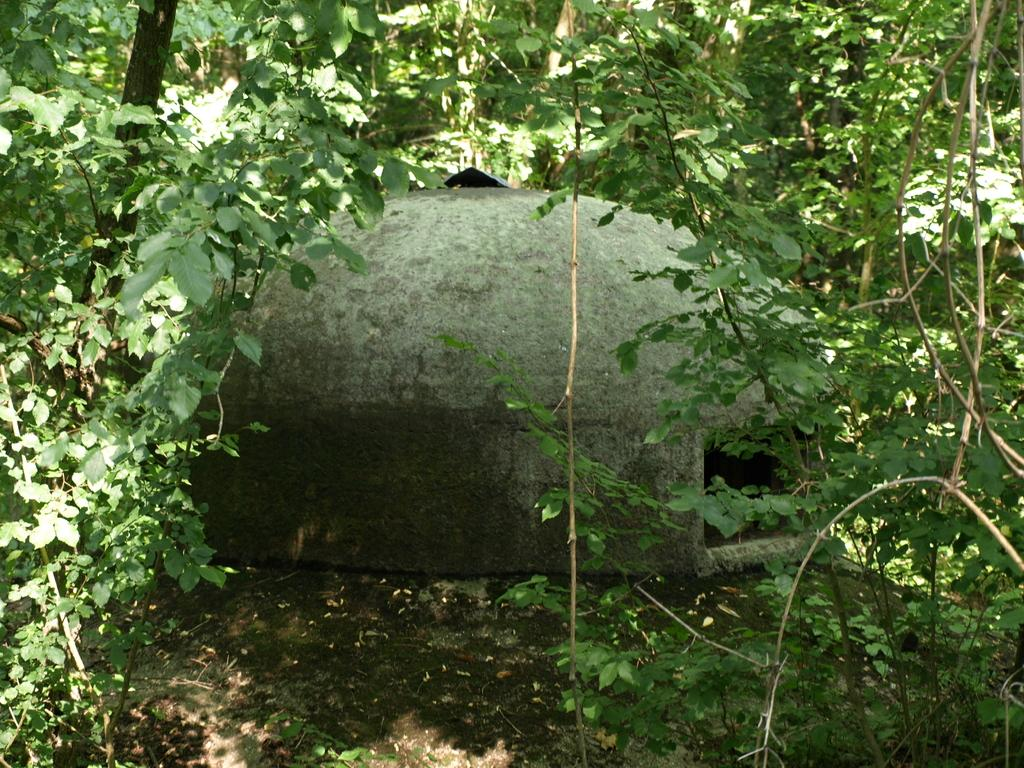What is the main subject in the center of the image? There is a house in the center of the image. What type of vegetation can be seen in the image? There are trees in the foreground and background of the image. What is the pathway visible at the bottom of the image? There is a walkway at the bottom of the image. What type of advertisement can be seen on the side of the house in the image? There is no advertisement present on the side of the house in the image. 